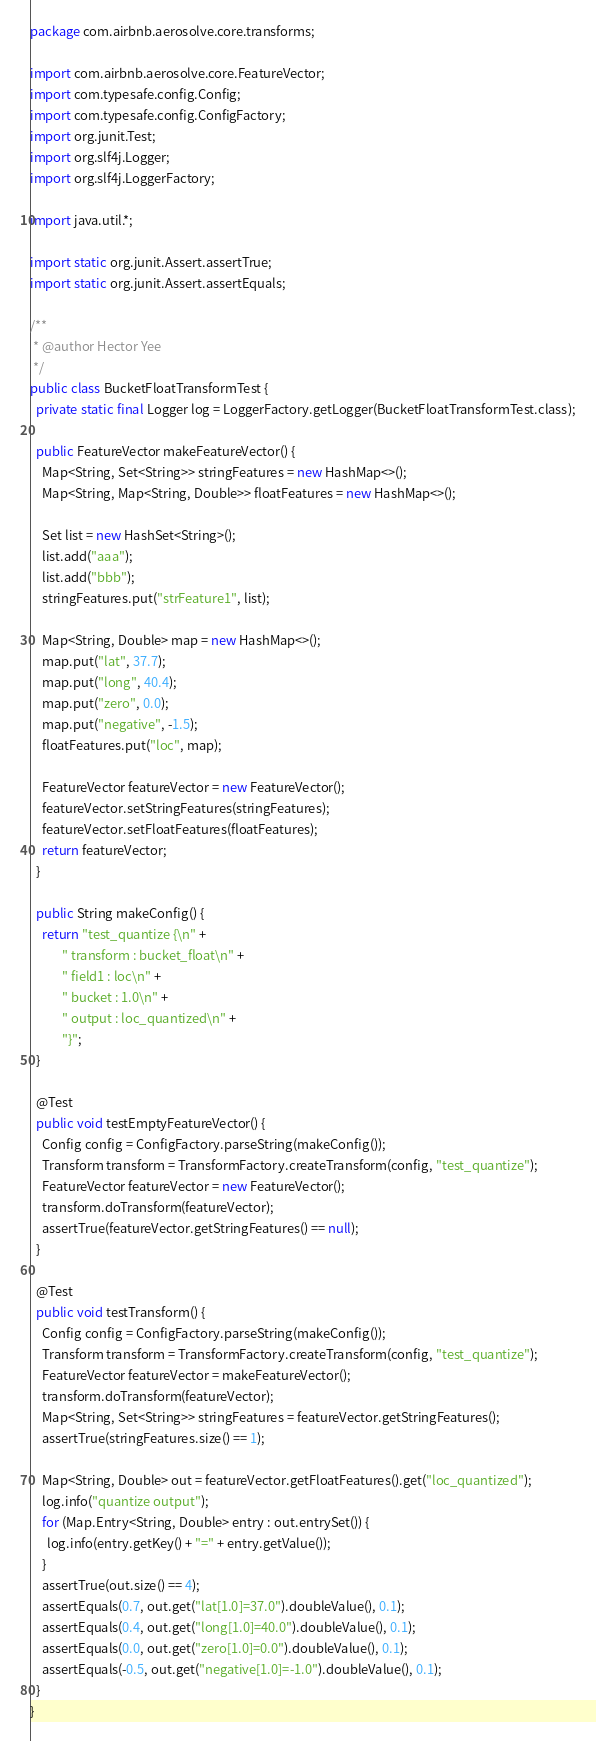Convert code to text. <code><loc_0><loc_0><loc_500><loc_500><_Java_>package com.airbnb.aerosolve.core.transforms;

import com.airbnb.aerosolve.core.FeatureVector;
import com.typesafe.config.Config;
import com.typesafe.config.ConfigFactory;
import org.junit.Test;
import org.slf4j.Logger;
import org.slf4j.LoggerFactory;

import java.util.*;

import static org.junit.Assert.assertTrue;
import static org.junit.Assert.assertEquals;

/**
 * @author Hector Yee
 */
public class BucketFloatTransformTest {
  private static final Logger log = LoggerFactory.getLogger(BucketFloatTransformTest.class);

  public FeatureVector makeFeatureVector() {
    Map<String, Set<String>> stringFeatures = new HashMap<>();
    Map<String, Map<String, Double>> floatFeatures = new HashMap<>();

    Set list = new HashSet<String>();
    list.add("aaa");
    list.add("bbb");
    stringFeatures.put("strFeature1", list);

    Map<String, Double> map = new HashMap<>();
    map.put("lat", 37.7);
    map.put("long", 40.4);
    map.put("zero", 0.0);
    map.put("negative", -1.5);
    floatFeatures.put("loc", map);

    FeatureVector featureVector = new FeatureVector();
    featureVector.setStringFeatures(stringFeatures);
    featureVector.setFloatFeatures(floatFeatures);
    return featureVector;
  }

  public String makeConfig() {
    return "test_quantize {\n" +
           " transform : bucket_float\n" +
           " field1 : loc\n" +
           " bucket : 1.0\n" +
           " output : loc_quantized\n" +
           "}";
  }
  
  @Test
  public void testEmptyFeatureVector() {
    Config config = ConfigFactory.parseString(makeConfig());
    Transform transform = TransformFactory.createTransform(config, "test_quantize");
    FeatureVector featureVector = new FeatureVector();
    transform.doTransform(featureVector);
    assertTrue(featureVector.getStringFeatures() == null);
  }

  @Test
  public void testTransform() {
    Config config = ConfigFactory.parseString(makeConfig());
    Transform transform = TransformFactory.createTransform(config, "test_quantize");
    FeatureVector featureVector = makeFeatureVector();
    transform.doTransform(featureVector);
    Map<String, Set<String>> stringFeatures = featureVector.getStringFeatures();
    assertTrue(stringFeatures.size() == 1);

    Map<String, Double> out = featureVector.getFloatFeatures().get("loc_quantized");
    log.info("quantize output");
    for (Map.Entry<String, Double> entry : out.entrySet()) {
      log.info(entry.getKey() + "=" + entry.getValue());
    }
    assertTrue(out.size() == 4);
    assertEquals(0.7, out.get("lat[1.0]=37.0").doubleValue(), 0.1);
    assertEquals(0.4, out.get("long[1.0]=40.0").doubleValue(), 0.1);
    assertEquals(0.0, out.get("zero[1.0]=0.0").doubleValue(), 0.1);
    assertEquals(-0.5, out.get("negative[1.0]=-1.0").doubleValue(), 0.1);
  }
}</code> 